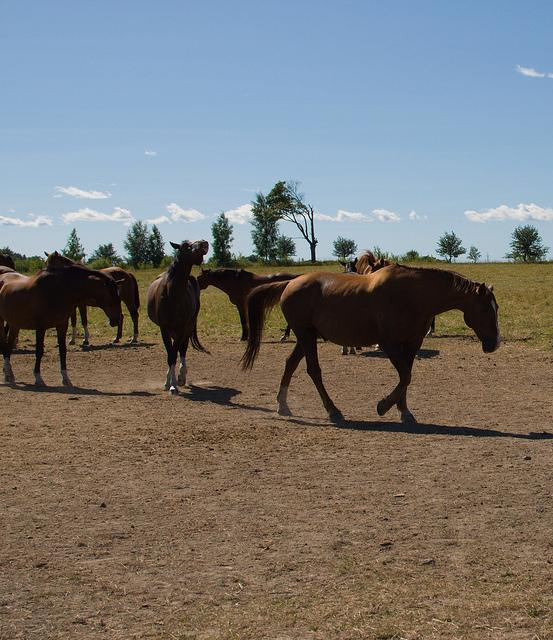This slowly moving horse is doing what? walking 